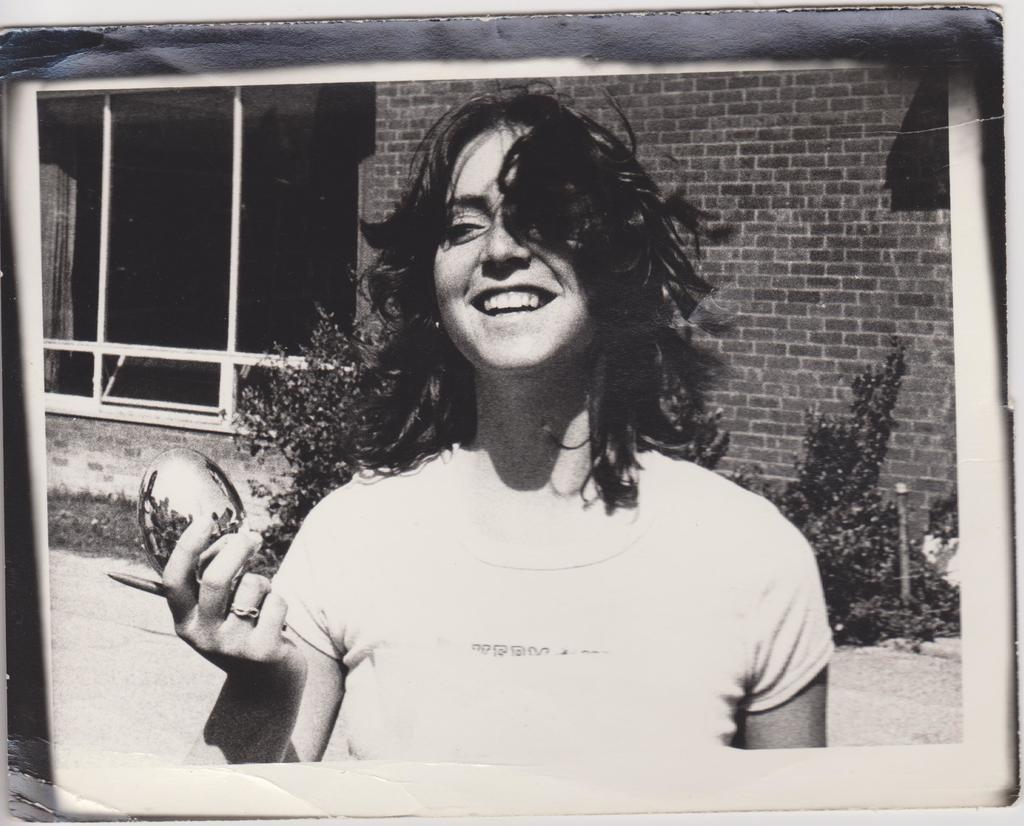Who is the main subject in the image? There is a girl in the center of the image. What can be seen in the background of the image? There are plants and a house in the background of the image. What type of knee injury is the laborer suffering from in the image? There is no laborer or knee injury present in the image; it features a girl and a background with plants and a house. 